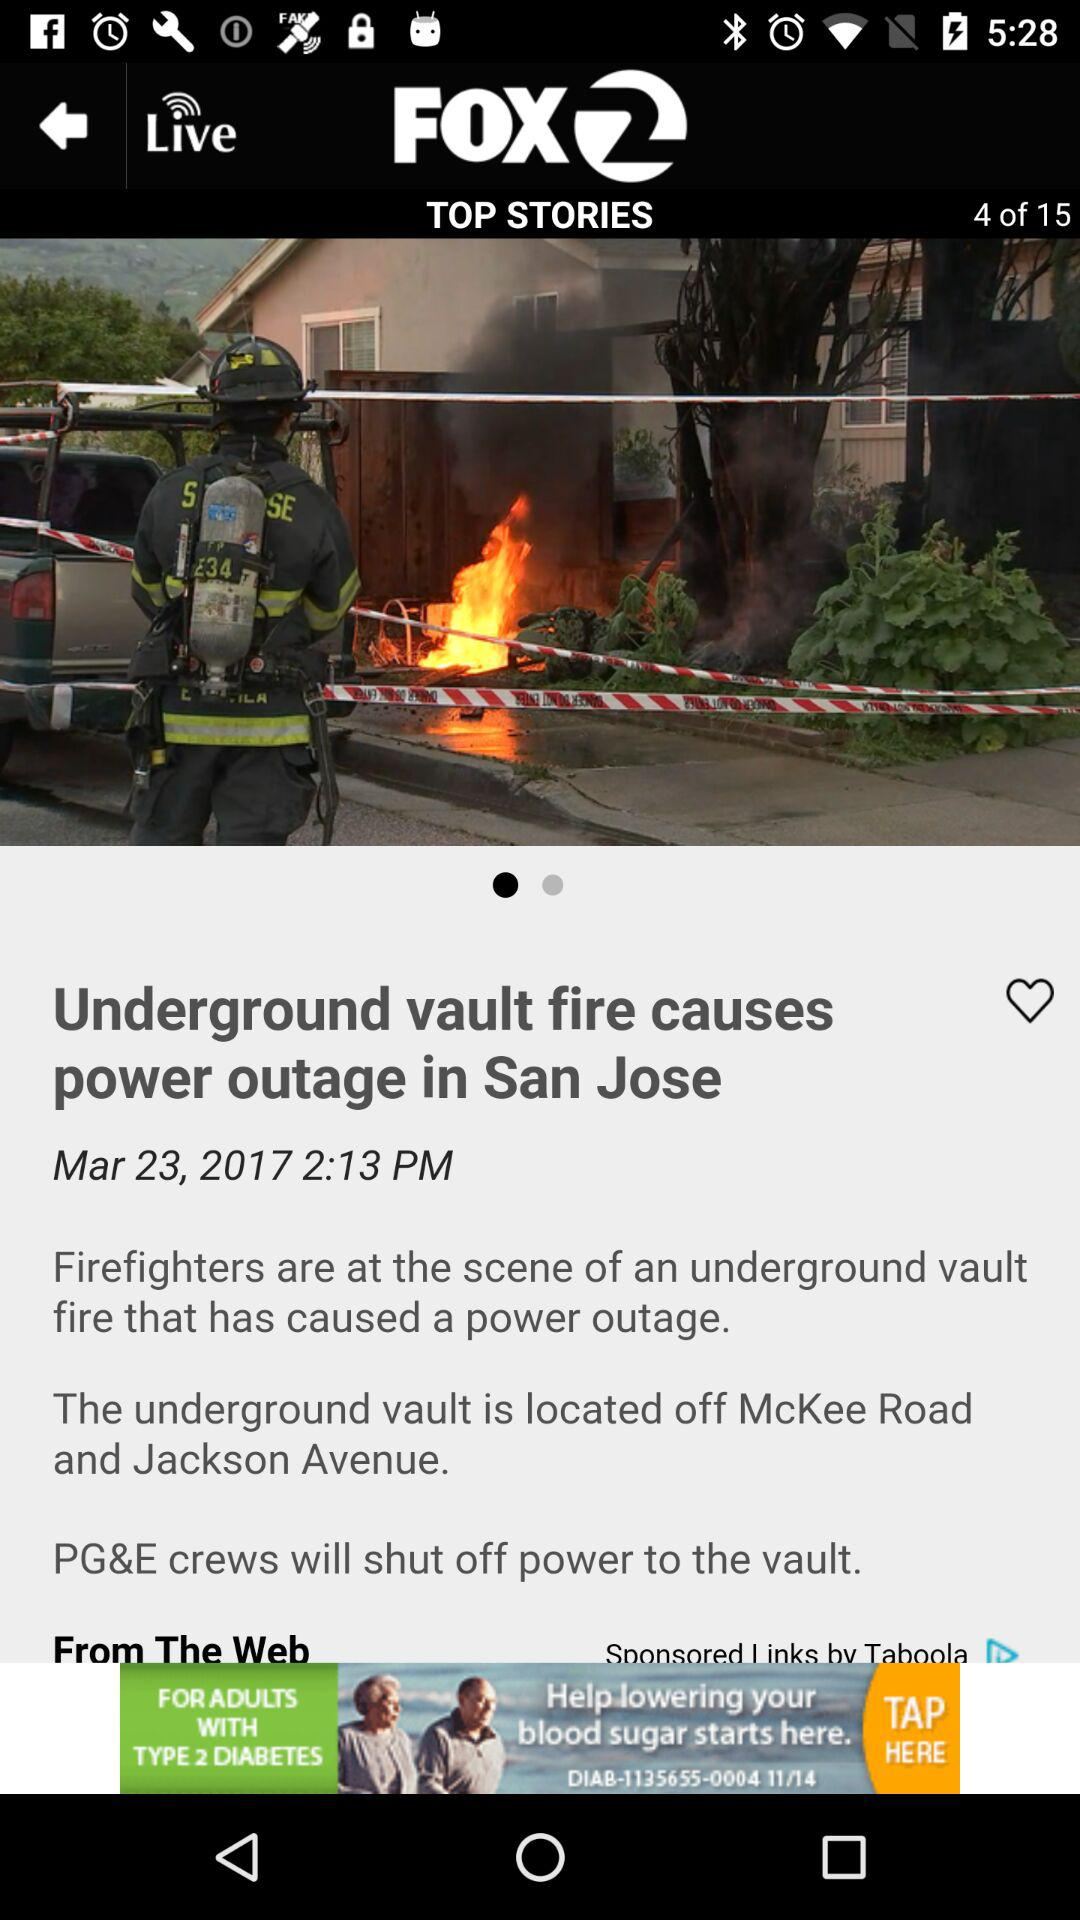At what time was the story "Underground vault fire causes power outage in San Jose" uploaded? The story was uploaded at 2:13 PM. 